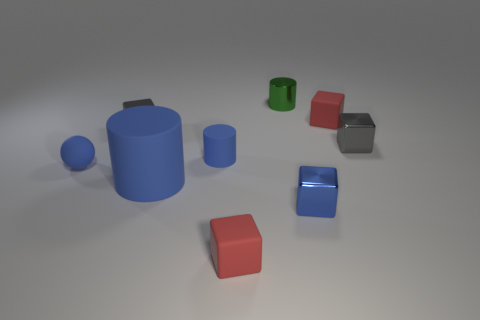How many objects are either cyan shiny blocks or red things right of the green metal cylinder?
Your answer should be compact. 1. Does the metallic cube in front of the sphere have the same size as the green shiny cylinder?
Offer a terse response. Yes. What number of other objects are there of the same size as the blue metallic cube?
Give a very brief answer. 7. What is the color of the sphere?
Your answer should be compact. Blue. There is a tiny gray block that is left of the big matte object; what material is it?
Keep it short and to the point. Metal. Are there an equal number of small blue objects behind the tiny blue ball and blue matte spheres?
Your answer should be compact. Yes. Is the shape of the big blue rubber object the same as the green object?
Your response must be concise. Yes. Are there any other things that are the same color as the rubber sphere?
Provide a succinct answer. Yes. What shape is the small blue object that is to the left of the green shiny cylinder and to the right of the ball?
Give a very brief answer. Cylinder. Are there an equal number of metallic blocks in front of the large thing and tiny blue things that are behind the tiny green metallic cylinder?
Make the answer very short. No. 